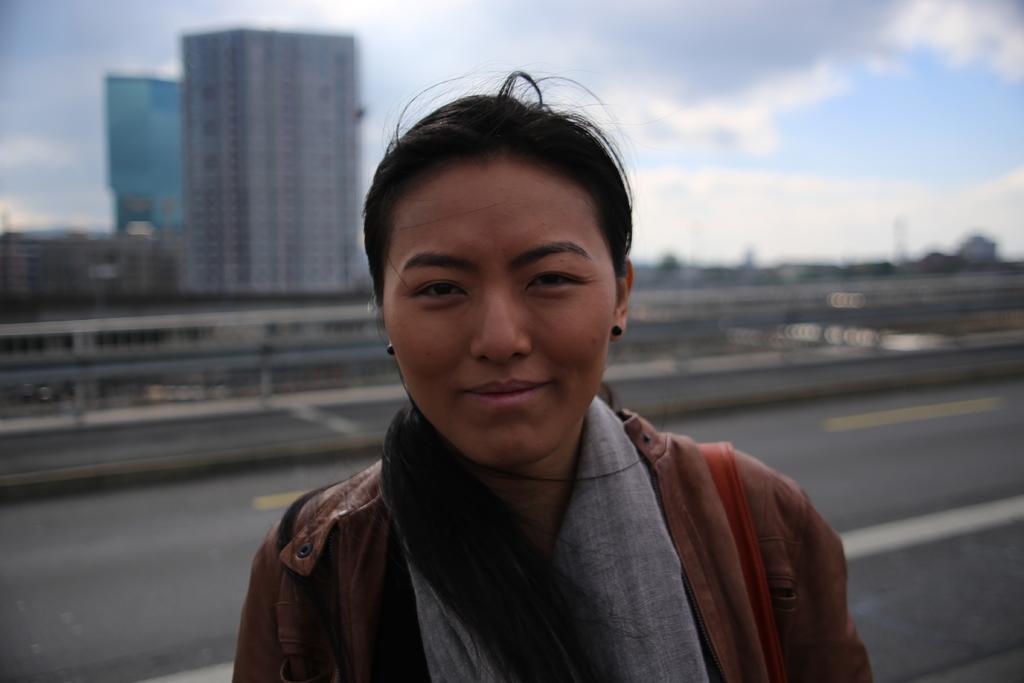How would you summarize this image in a sentence or two? In the foreground of the image there is a woman. There is a road. In the background of the image there are buildings, trees, sky and clouds. 